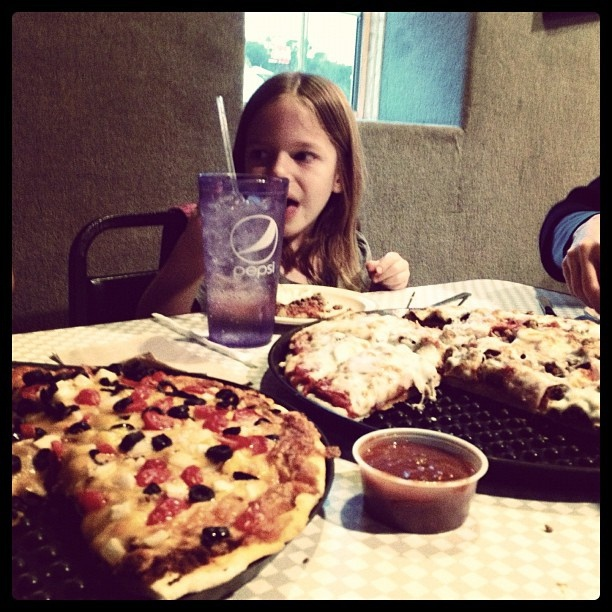Describe the objects in this image and their specific colors. I can see dining table in black, lightyellow, khaki, and maroon tones, pizza in black, tan, khaki, and maroon tones, pizza in black, tan, lightyellow, and maroon tones, people in black, maroon, brown, and tan tones, and cup in black, purple, gray, and darkgray tones in this image. 